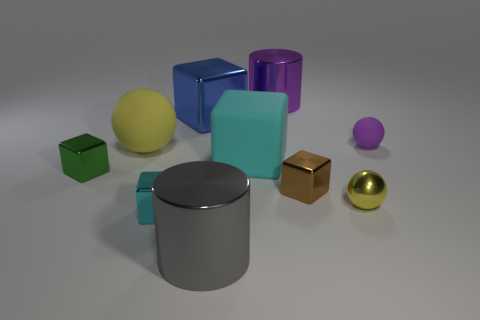Subtract 2 cubes. How many cubes are left? 3 Subtract all red blocks. Subtract all gray cylinders. How many blocks are left? 5 Subtract all spheres. How many objects are left? 7 Add 6 yellow metallic things. How many yellow metallic things exist? 7 Subtract 0 brown cylinders. How many objects are left? 10 Subtract all small brown matte spheres. Subtract all small rubber things. How many objects are left? 9 Add 2 tiny matte spheres. How many tiny matte spheres are left? 3 